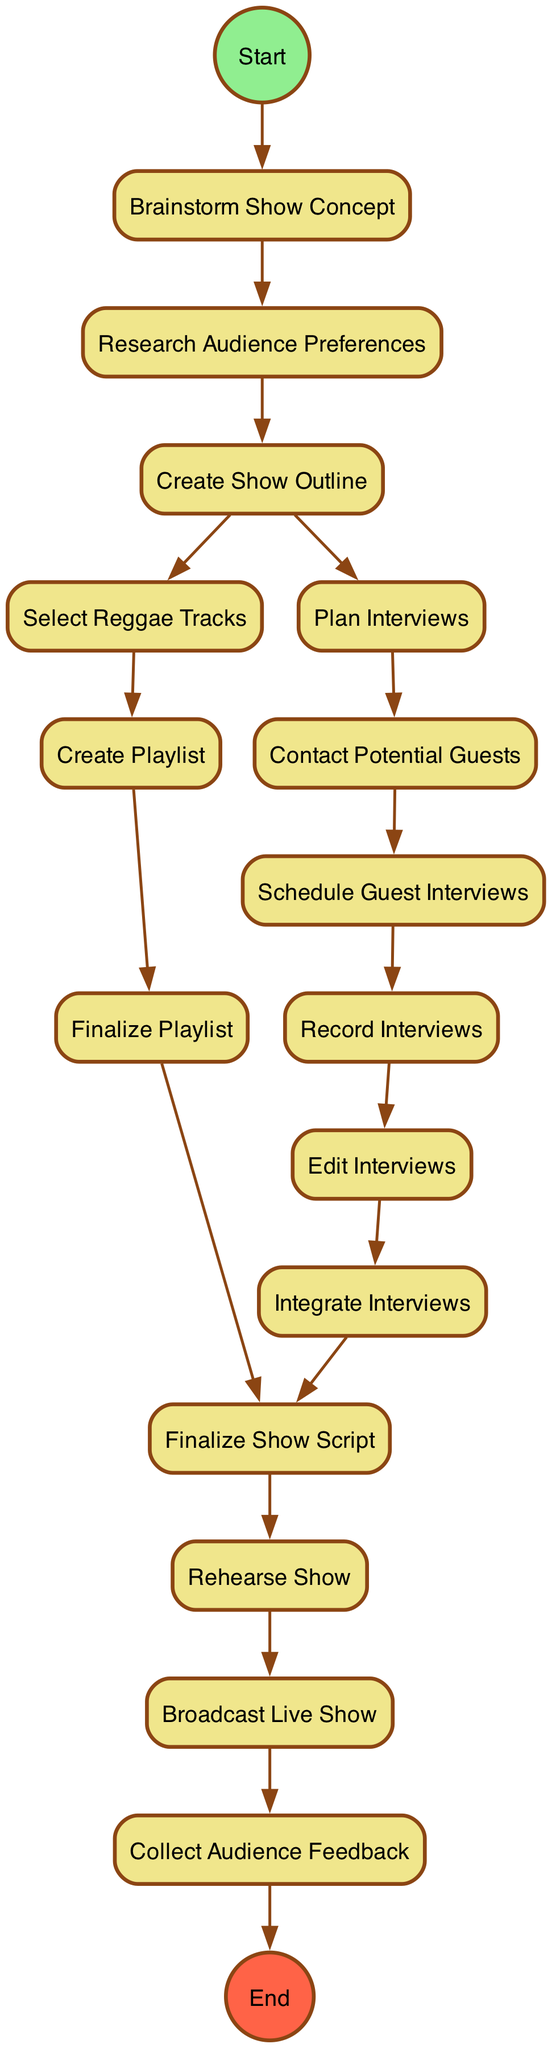What is the first activity in the diagram? The first activity is represented as "Brainstorm Show Concept," which connects directly to the start node, indicating it is the first action taken.
Answer: Brainstorm Show Concept How many activities are present in the diagram? By counting all unique activities listed within the diagram, there are a total of 15 activities from start to completion, including the activities leading to collecting feedback.
Answer: 15 Which activity comes immediately after "Create Show Outline"? The "Create Show Outline" activity has two outgoing transitions: one to "Select Reggae Tracks" and another to "Plan Interviews." Since both options are available, the question is about the activities immediately connected, and they are both valid next steps.
Answer: Select Reggae Tracks and Plan Interviews What is the last activity before broadcasting the show? To identify the last step before the show is broadcasted, we look at the activity that transitions directly into "Broadcast Live Show." That activity is "Rehearse Show."
Answer: Rehearse Show How many transitions are there leading out from "Contact Potential Guests"? The "Contact Potential Guests" activity has one outgoing transition, which is to "Schedule Guest Interviews," indicating the next step in the process after making contact.
Answer: 1 Which activity needs to happen before finalizing the show script? There are two activities that need to be completed before "Finalize Show Script": "Integrate Interviews" and "Finalize Playlist," as both have transitions that lead into the finalization step.
Answer: Integrate Interviews and Finalize Playlist What activity follows "Broadcast Live Show"? After "Broadcast Live Show," the transition leads to "Collect Audience Feedback," representing the next step in assessing the success of the broadcast.
Answer: Collect Audience Feedback What is the total number of edges in the diagram? By counting all the lines indicating transitions between activities, there are a total of 14 edges that connect the activities of the entire process, showcasing all the flow paths.
Answer: 14 When does the feedback collection occur in the process? The feedback collection occurs as the last activity in the process after broadcasting the live show, which indicates that it takes place after the primary show has aired and ends the flow.
Answer: After broadcasting the live show 